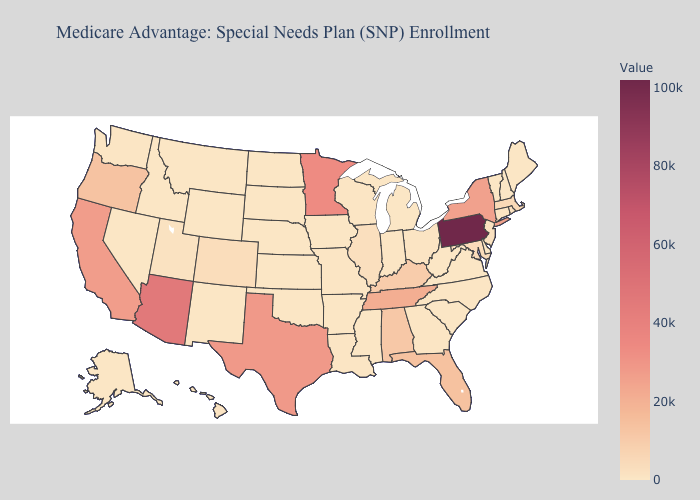Does Missouri have the lowest value in the USA?
Short answer required. No. Which states hav the highest value in the Northeast?
Write a very short answer. Pennsylvania. Which states have the lowest value in the USA?
Quick response, please. Alaska, Delaware, Iowa, Kansas, Maine, Montana, North Dakota, New Hampshire, Nevada, Oklahoma, South Carolina, South Dakota, Virginia, Vermont, West Virginia, Wyoming. Which states have the lowest value in the USA?
Be succinct. Alaska, Delaware, Iowa, Kansas, Maine, Montana, North Dakota, New Hampshire, Nevada, Oklahoma, South Carolina, South Dakota, Virginia, Vermont, West Virginia, Wyoming. Which states hav the highest value in the MidWest?
Write a very short answer. Minnesota. Does Kansas have the highest value in the MidWest?
Short answer required. No. Does Pennsylvania have the highest value in the USA?
Answer briefly. Yes. Does New Hampshire have the lowest value in the USA?
Give a very brief answer. Yes. Among the states that border Tennessee , which have the lowest value?
Keep it brief. Virginia. 